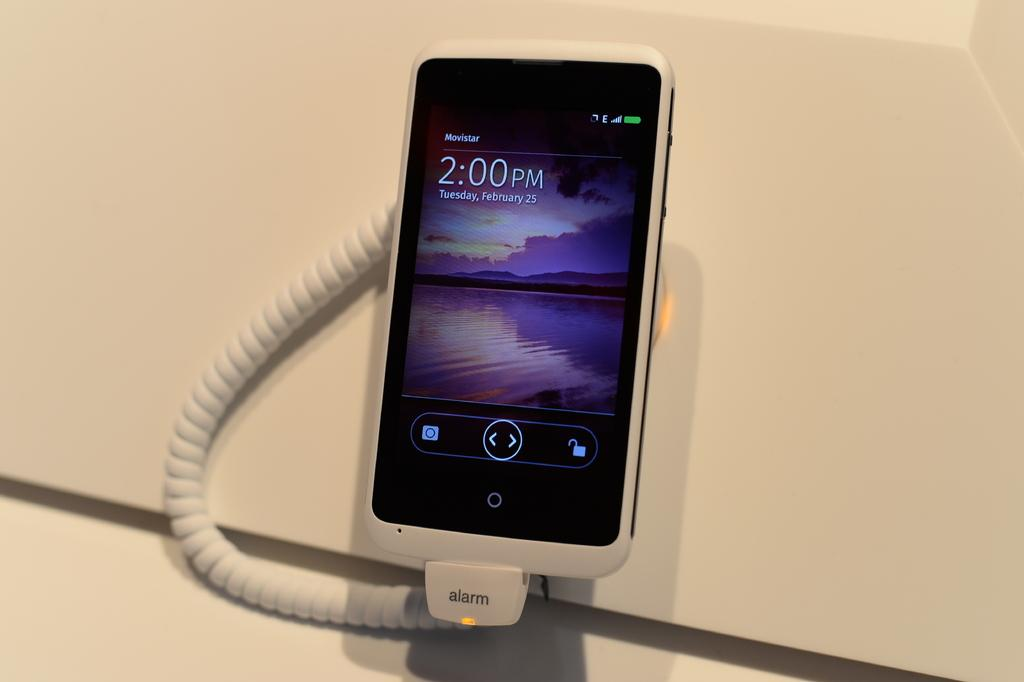<image>
Create a compact narrative representing the image presented. A movistar phone hooked up to an old telephone style cord that says alarm. 